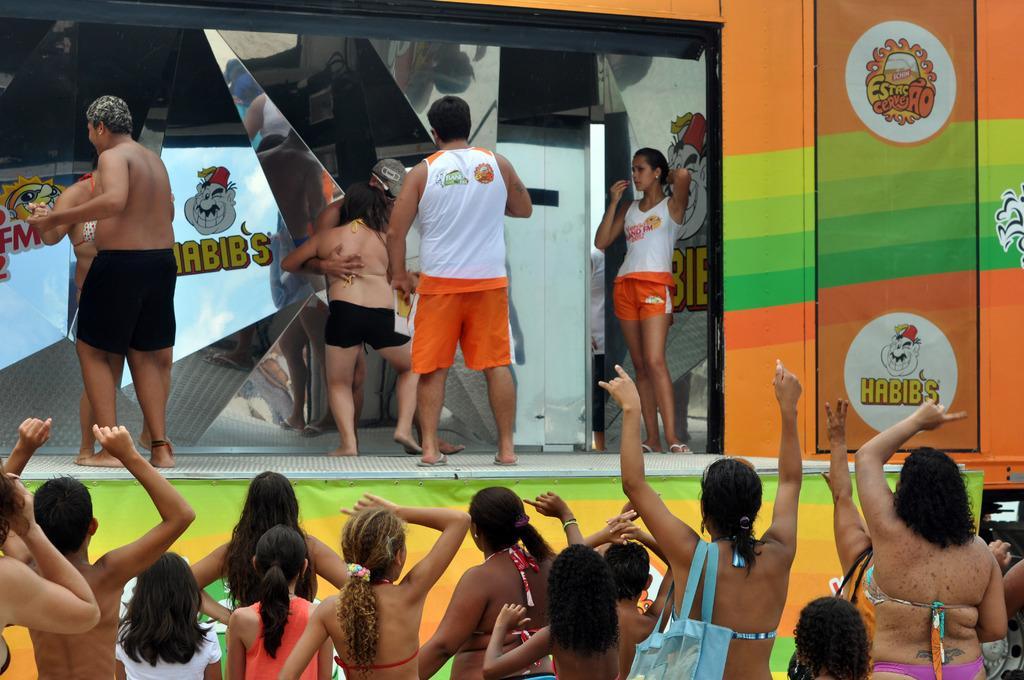Can you describe this image briefly? There are people and we can see stage. We can see mirrors, reflection, poster and information. We can see hoarding. 